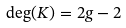<formula> <loc_0><loc_0><loc_500><loc_500>\deg ( K ) = 2 g - 2</formula> 